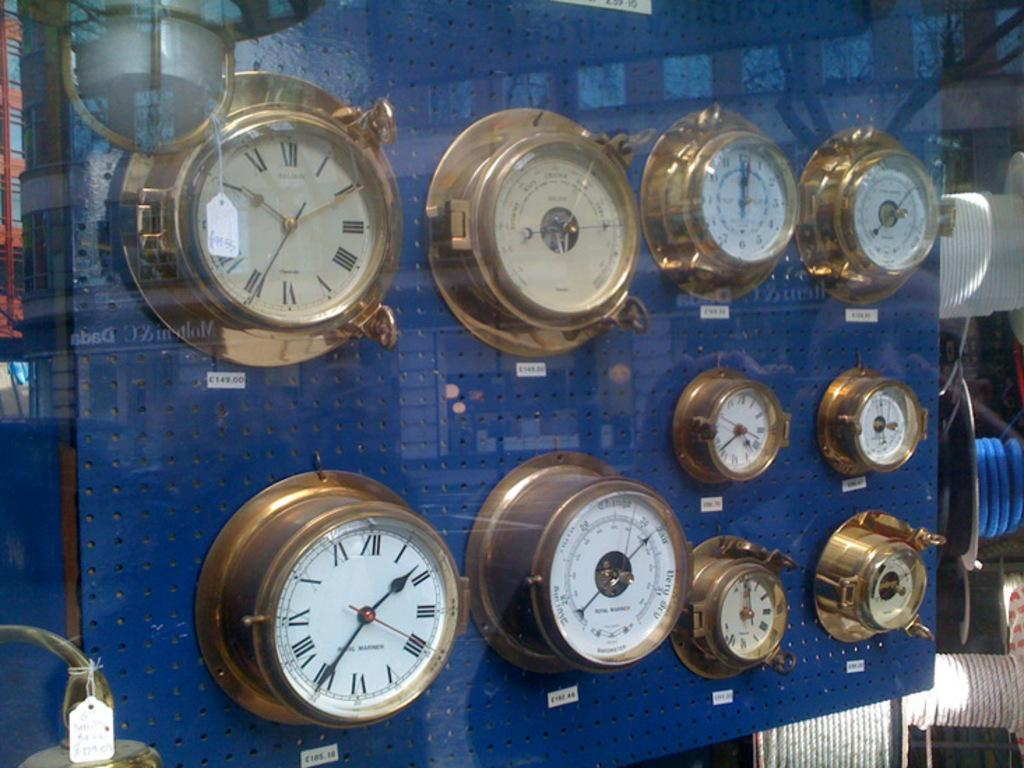What is in the foreground of the image? There are many blocks in the foreground of the image. How are the blocks connected or organized? The blocks are attached to a blue board. Are there any additional details about the blocks? Price tags are present on the blocks. What can be seen in the background of the image? There are ropes visible in the background of the image. How does the image address the issue of pollution? The image does not address the issue of pollution, as it primarily features blocks attached to a blue board with price tags. 